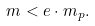Convert formula to latex. <formula><loc_0><loc_0><loc_500><loc_500>m < e \cdot m _ { p } .</formula> 